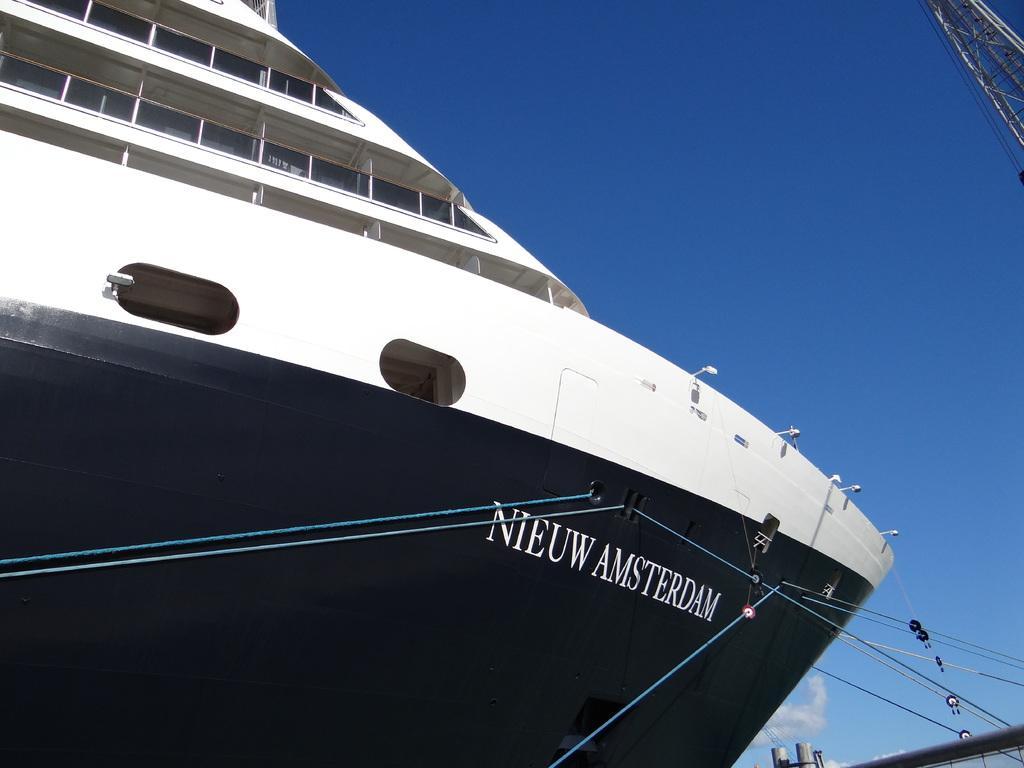Please provide a concise description of this image. In front of the image there is a cruise ship with glass windows, lamps and cables, at the top right of the image there is a metal tower, behind the ship there are two coolants and a metal rod, in the sky there are clouds. 